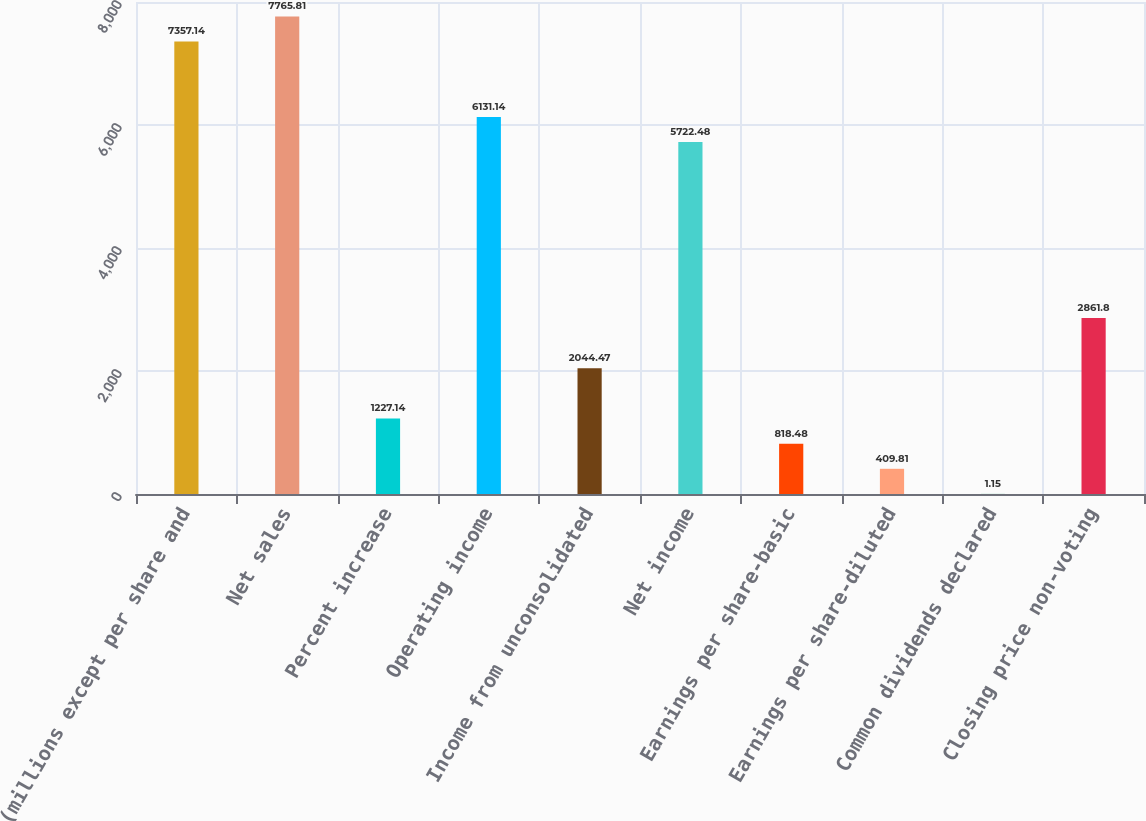<chart> <loc_0><loc_0><loc_500><loc_500><bar_chart><fcel>(millions except per share and<fcel>Net sales<fcel>Percent increase<fcel>Operating income<fcel>Income from unconsolidated<fcel>Net income<fcel>Earnings per share-basic<fcel>Earnings per share-diluted<fcel>Common dividends declared<fcel>Closing price non-voting<nl><fcel>7357.14<fcel>7765.81<fcel>1227.14<fcel>6131.14<fcel>2044.47<fcel>5722.48<fcel>818.48<fcel>409.81<fcel>1.15<fcel>2861.8<nl></chart> 